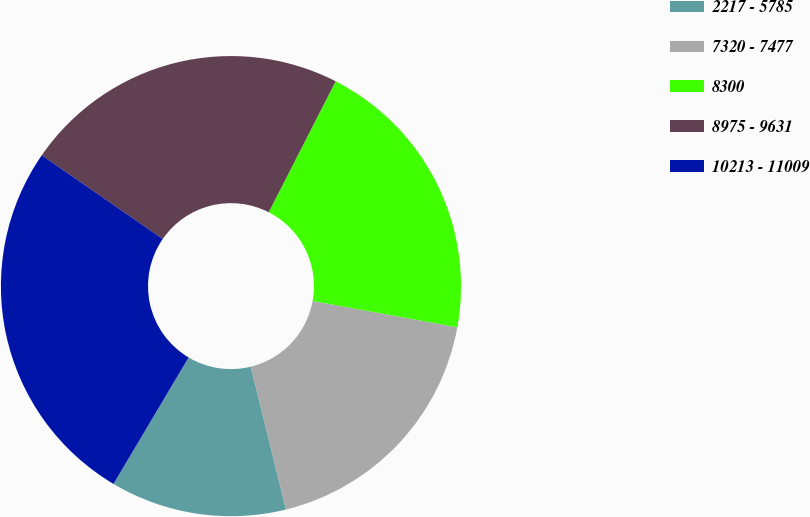Convert chart. <chart><loc_0><loc_0><loc_500><loc_500><pie_chart><fcel>2217 - 5785<fcel>7320 - 7477<fcel>8300<fcel>8975 - 9631<fcel>10213 - 11009<nl><fcel>12.37%<fcel>18.3%<fcel>20.34%<fcel>22.89%<fcel>26.1%<nl></chart> 